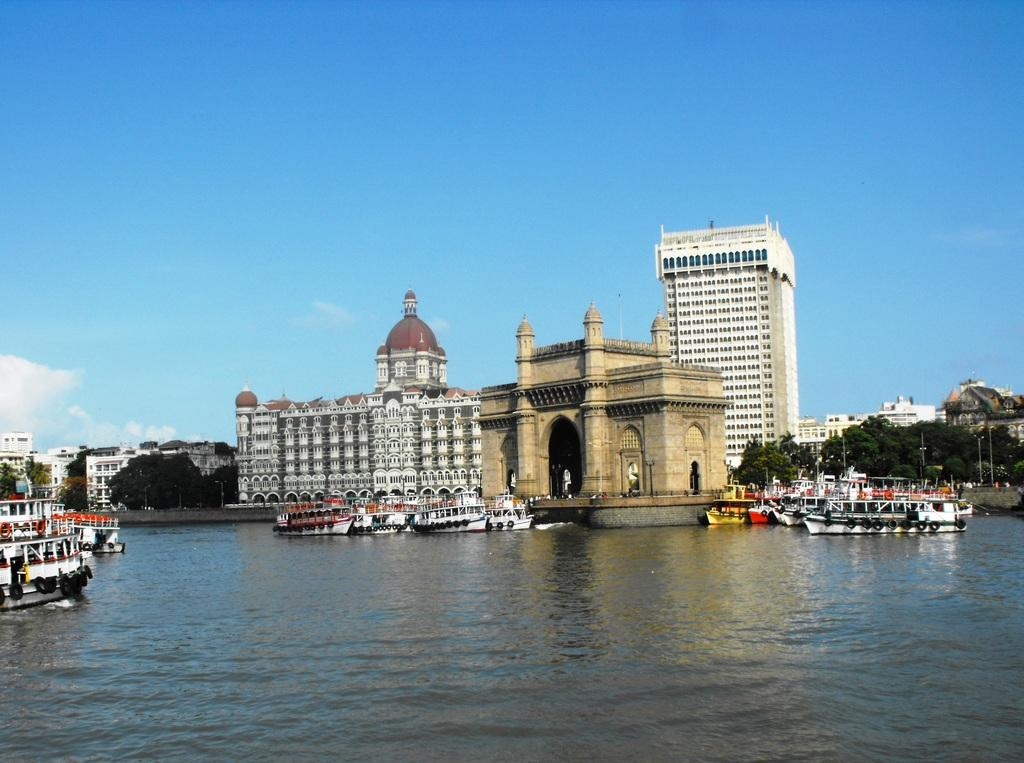What is in the foreground of the picture? There is a water body in the foreground of the picture. What can be seen in the water? There are ships in the water. What is located in the center of the picture? There are buildings, trees, poles, and the Indian Gate in the center of the picture. What is the weather like in the image? The sky is sunny in the image. What type of print can be seen on the books in the image? There are no books present in the image; it features a water body, ships, buildings, trees, poles, and the Indian Gate. What scientific discoveries are being discussed by the people near the Indian Gate? There is no indication of any scientific discussions or people near the Indian Gate in the image. 